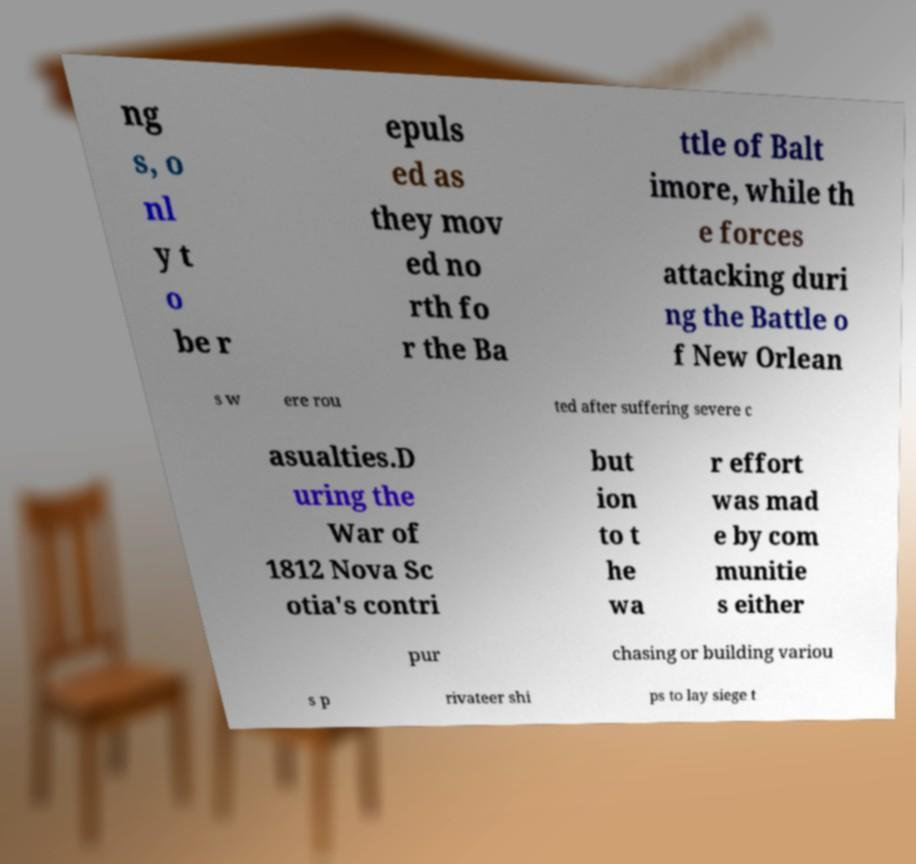There's text embedded in this image that I need extracted. Can you transcribe it verbatim? ng s, o nl y t o be r epuls ed as they mov ed no rth fo r the Ba ttle of Balt imore, while th e forces attacking duri ng the Battle o f New Orlean s w ere rou ted after suffering severe c asualties.D uring the War of 1812 Nova Sc otia's contri but ion to t he wa r effort was mad e by com munitie s either pur chasing or building variou s p rivateer shi ps to lay siege t 